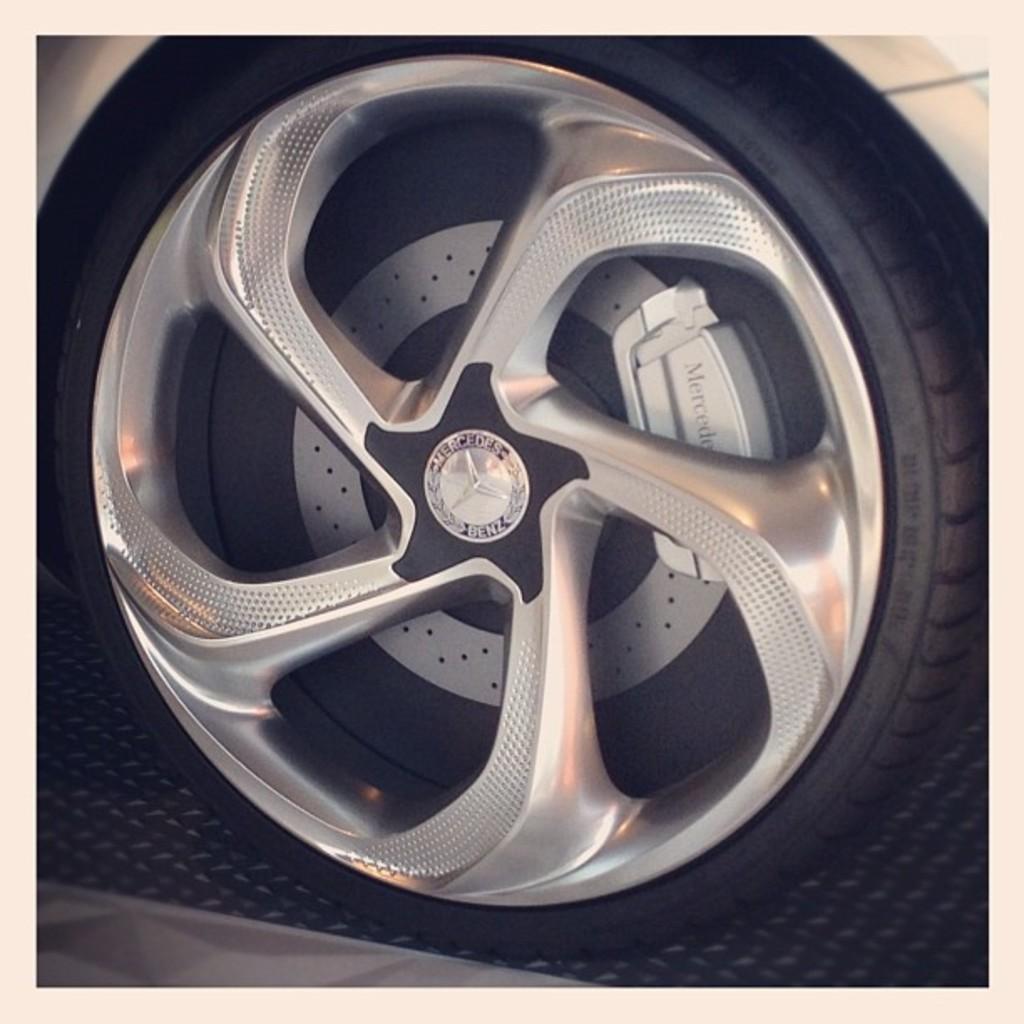Can you describe this image briefly? This picture is an edited picture. In this image there is a vehicle and there is a text on the wheel. 